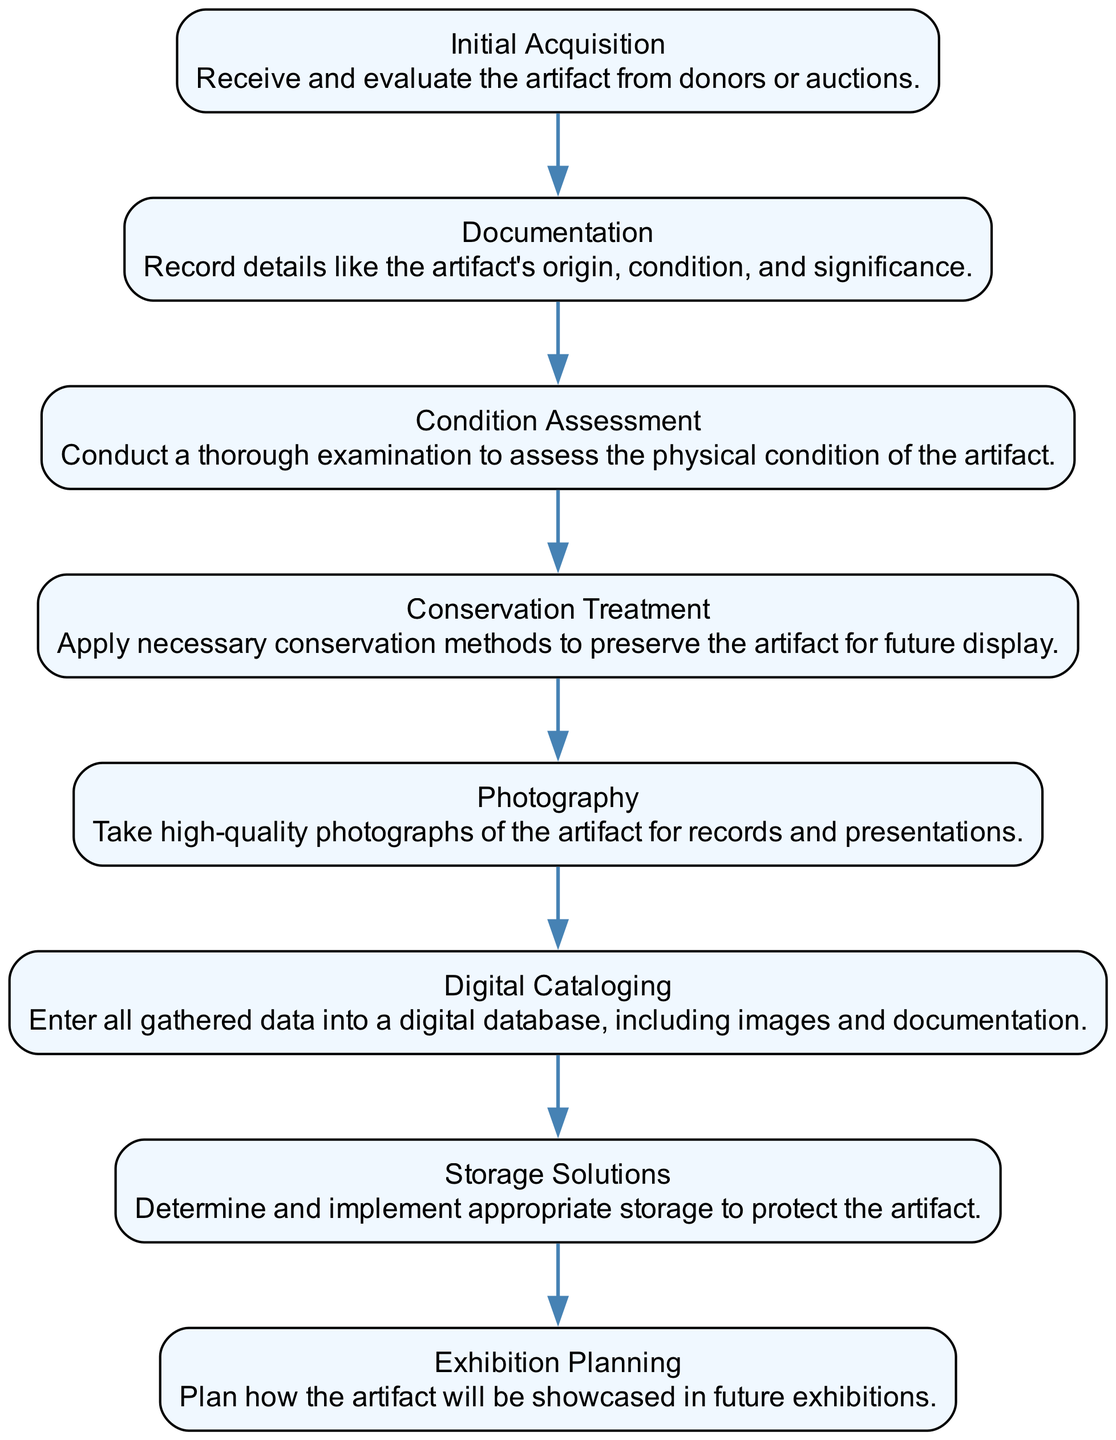What is the first step in the artifact cataloging procedure? The first step is "Initial Acquisition," which involves receiving and evaluating the artifact from donors or auctions.
Answer: Initial Acquisition How many steps are included in the diagram? There are eight distinct steps presented in the flowchart.
Answer: 8 What is the fifth step of the cataloging process? The fifth step is "Photography," which involves taking high-quality photographs of the artifact for records and presentations.
Answer: Photography Which step follows the "Condition Assessment"? After "Condition Assessment," the next step is "Conservation Treatment," where necessary conservation methods are applied to preserve the artifact.
Answer: Conservation Treatment What is the last step in the artifact cataloging procedure? The final step is "Exhibition Planning," which involves planning how the artifact will be showcased in future exhibitions.
Answer: Exhibition Planning What is the relationship between "Digital Cataloging" and "Photography"? "Photography" occurs before "Digital Cataloging" as high-quality photographs are taken to document the artifact before entering this information into a digital database.
Answer: Photography → Digital Cataloging What is assessed during the "Condition Assessment"? The physical condition of the artifact is thoroughly examined during the "Condition Assessment" step.
Answer: Physical condition What action is taken to preserve the artifact identified in "Conservation Treatment"? Necessary conservation methods are applied in the "Conservation Treatment" step to ensure the artifact is preserved for future display.
Answer: Conservation methods 